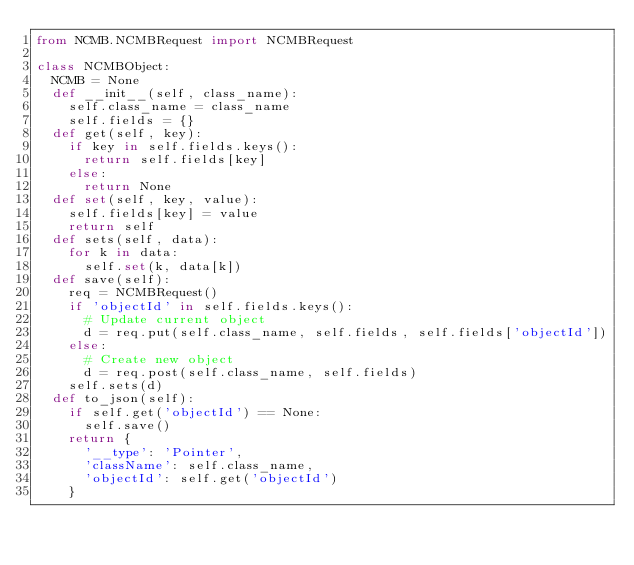Convert code to text. <code><loc_0><loc_0><loc_500><loc_500><_Python_>from NCMB.NCMBRequest import NCMBRequest

class NCMBObject:
  NCMB = None
  def __init__(self, class_name):
    self.class_name = class_name
    self.fields = {}
  def get(self, key):
    if key in self.fields.keys():
      return self.fields[key]
    else:
      return None
  def set(self, key, value):
    self.fields[key] = value
    return self
  def sets(self, data):
    for k in data:
      self.set(k, data[k])
  def save(self):
    req = NCMBRequest()
    if 'objectId' in self.fields.keys():
      # Update current object
      d = req.put(self.class_name, self.fields, self.fields['objectId'])
    else:
      # Create new object
      d = req.post(self.class_name, self.fields)
    self.sets(d)
  def to_json(self):
    if self.get('objectId') == None:
      self.save()
    return {
      '__type': 'Pointer',
      'className': self.class_name,
      'objectId': self.get('objectId')
    }
</code> 